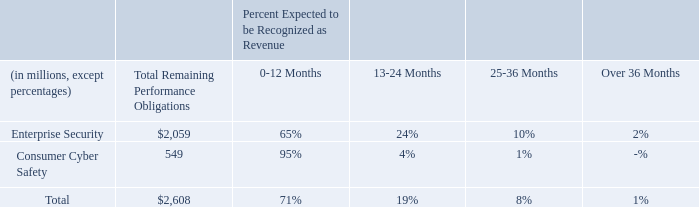Remaining performance obligations
Remaining performance obligations represent contracted revenue that has not been recognized, which include contract liabilities and amounts that will be billed and recognized as revenue in future periods. As of March 29, 2019, we had $2,608 million of remaining performance obligations, which does not include customer deposit liabilities of approximately $505 million, and the approximate percentages expected to be recognized as revenue in the future are as follows:
Percentages may not add to 100% due to rounding.
As of March 29, 2019, how much remaining performance obligations are there? $2,608 million. What is the Total Remaining Performance Obligations for Enterprise Security?
Answer scale should be: million. 2,059. What is the Total Remaining Performance Obligations for Consumer Cyber Safety?
Answer scale should be: million. 549. What is the percentage constitution of the Total Remaining Performance Obligations of Consumer Cyber Safety among the total remaining performance obligations?
Answer scale should be: percent. 549/2,608
Answer: 21.05. What is the difference in Total Remaining Performance Obligations for Consumer Cyber Safety and Enterprise Security?
Answer scale should be: million. 2,059-549
Answer: 1510. What is Total Remaining Performance Obligations for Enterprise Security expressed as a percentage of total obligations?
Answer scale should be: percent. 2,059/2,608
Answer: 78.95. 